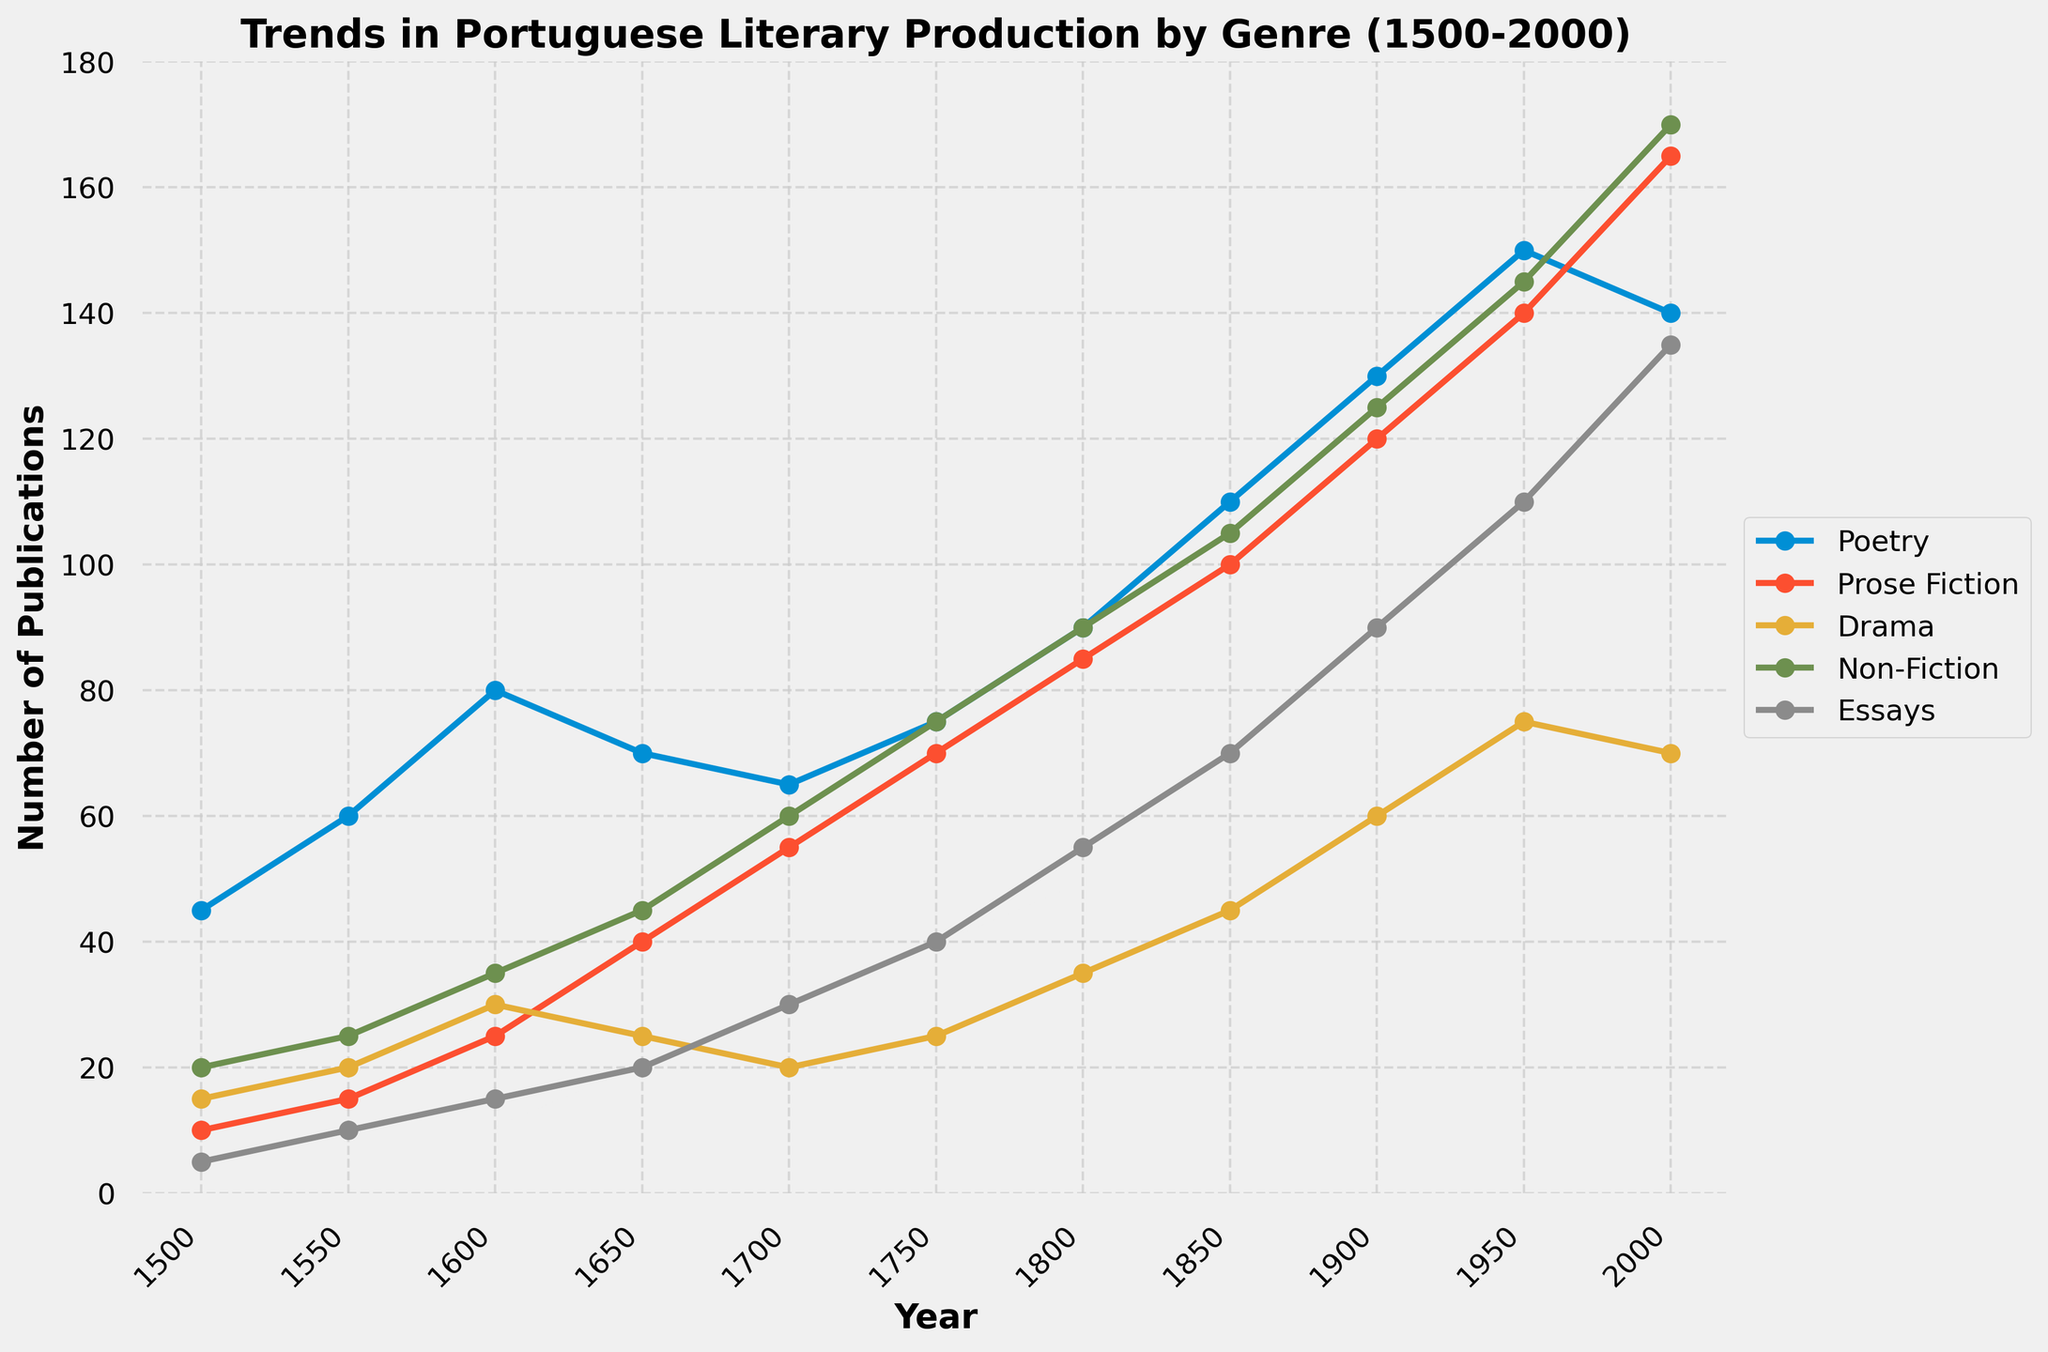What genre had the highest number of publications in 2000? The figure shows the number of publications for each genre in 2000. By locating the 2000 mark on the x-axis and comparing the data points for each genre, it is clear that 'Essays' had the highest number of publications.
Answer: Essays Which genre saw the steepest increase in publications between 1500 and 2000? To determine which genre experienced the steepest increase, we need to compare the changes in the number of publications from 1500 to 2000 for each genre. 'Essays' increased from 5 to 135, which is a 130 publicaitons increase, the steepest increase among all genres.
Answer: Essays Between which two periods did Poetry see a decrease in its number of publications? By observing the line representing Poetry, we see a downward slope between 1600 and 1650, indicating that the number of publications decreased from 80 to 70.
Answer: 1600 to 1650 How many publications did Non-Fiction have in the year 1800? Look at the Non-Fiction genre line and locate the data point for the year 1800 on the x-axis. The y-axis value corresponding to 1800 for Non-Fiction is 90 publications.
Answer: 90 Which genre had the lowest number of publications in 1500, and how many did it have? By looking at the data points for each genre in the year 1500, 'Essays' had the lowest number of publications at 5.
Answer: Essays, 5 Comparing 1700 and 1800, which genre had the most significant percentage increase? The percentage increase for each genre can be calculated as ((value in 1800 - value in 1700) / value in 1700) * 100. Essays saw an increase from 30 in 1700 to 55 in 1800 which is ((55-30)/30)*100 ≈ 83.3%, the highest percentage increase among the genres.
Answer: Essays Did any genre experience a decrease in publications over the entire period from 1500 to 2000? Examining the trends for each genre from 1500 to 2000, no lines show a decreasing trend over the entire period.
Answer: No What is the overall trend for Prose Fiction's publications from 1500 to 2000? By observing the Prose Fiction line, it starts at 10 in 1500 and increases smoothly to 165 by 2000, indicating a steady upward trend over this period.
Answer: Steady increase Which genre had equal numbers of publications in any two distinct years? Comparing values across the years, Drama had 25 publications in both 1600 and 1750.
Answer: Drama In 1950, which genre had publications closest in number to the publications of Drama? Checking the publications in 1950, Drama had 75 publications. Non-Fiction had 145 and Essays had 110, with Prose Fiction at 140 and Poetry at 150. Essays had 110 publications, closest to Drama's 75.
Answer: Essays 